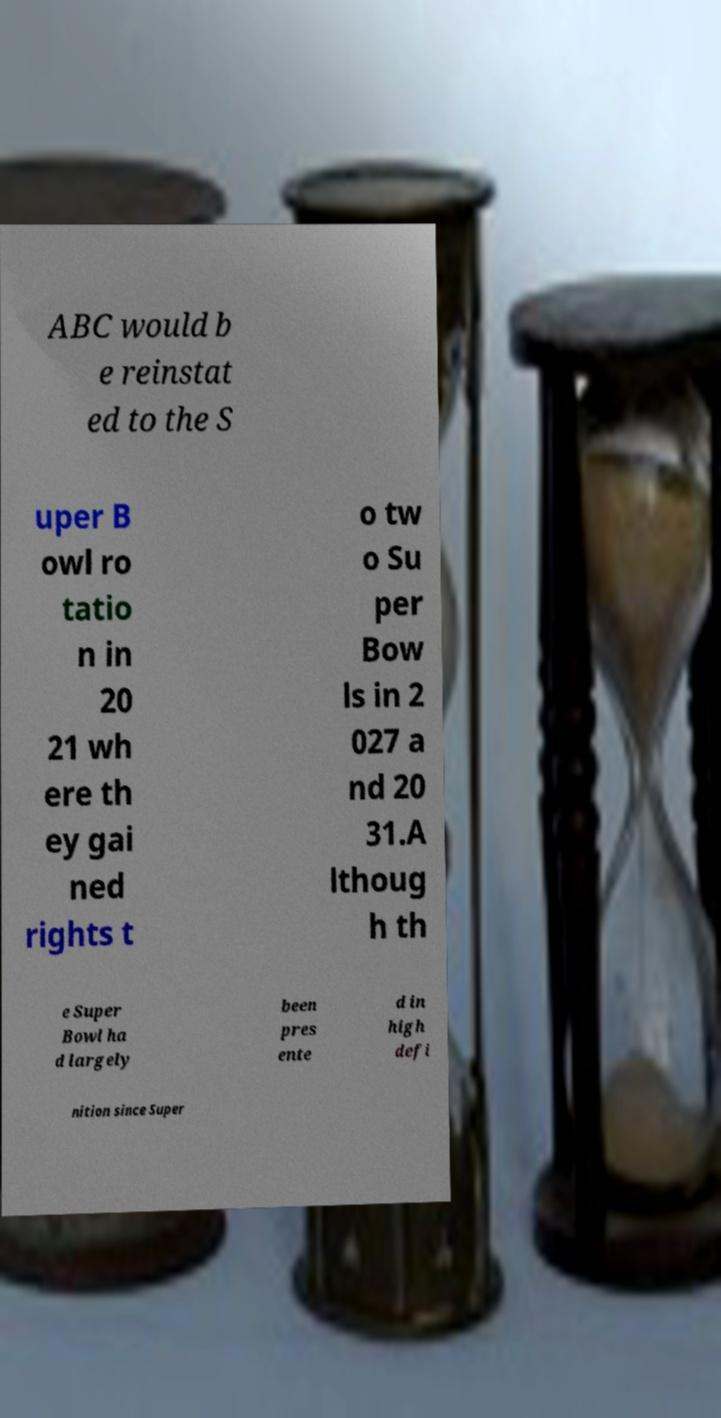Can you accurately transcribe the text from the provided image for me? ABC would b e reinstat ed to the S uper B owl ro tatio n in 20 21 wh ere th ey gai ned rights t o tw o Su per Bow ls in 2 027 a nd 20 31.A lthoug h th e Super Bowl ha d largely been pres ente d in high defi nition since Super 